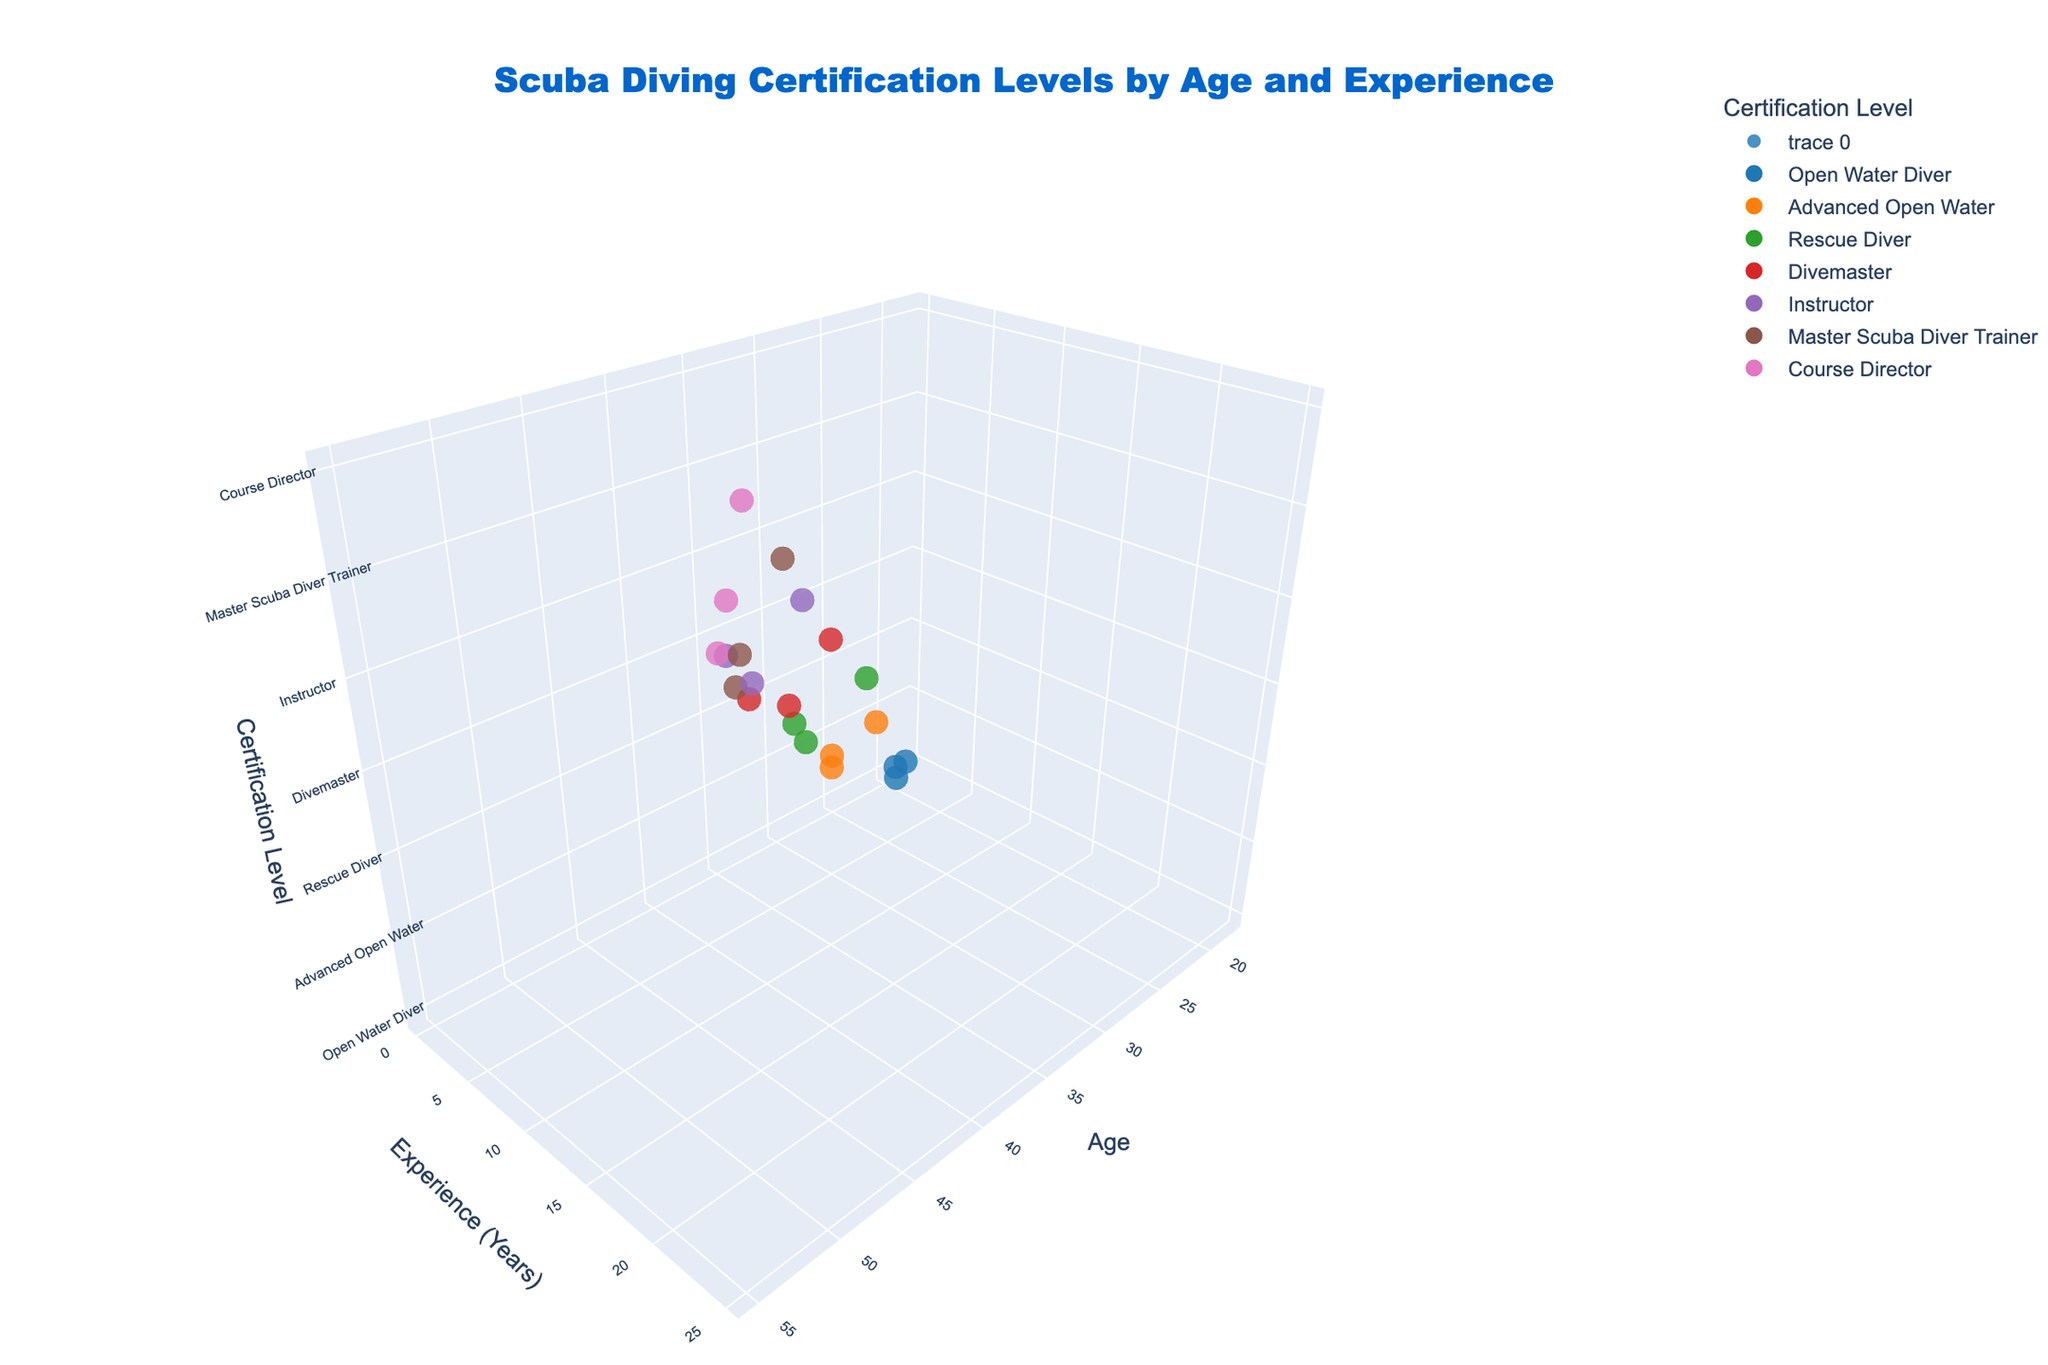What is the title of the plot? The title is usually positioned at the top-middle of the figure, it is typically larger and bolder than other text elements.
Answer: Scuba Diving Certification Levels by Age and Experience At what age does the data point for 'Master Scuba Diver Trainer' with 18 years of experience occur? Follow the x-axis to locate the age and then check the data point matching 'Master Scuba Diver Trainer' with 18 years of experience.
Answer: 48 Which certification level has the highest number of data points? Observe the number of markers associated with each certification level across the 3D plot.
Answer: Open Water Diver What age range covers 'Course Director' certification levels? Look at the x-axis values related to 'Course Director' markers to determine the age range.
Answer: 45 to 55 What is the relationship between age and experience? Observe the trend by comparing the positions of markers with respect to age and experience axes—generally, older individuals have more experience.
Answer: Positive correlation What are the ages of individuals with 'Instructor' certification? Identify the points labeled 'Instructor' and observe their positions along the x-axis (age).
Answer: 35, 42, 43 Is there any 'Open Water Diver' certification for individuals above age 25? Look for 'Open Water Diver' markers and check if any of them are positioned beyond age 25 on the x-axis.
Answer: No Compare the ages and experience years of the youngest and oldest 'Divemaster' certified individuals. Identify the 'Divemaster' points and find the minimum and maximum age and corresponding experience years for each.
Answer: Youngest: 30 years, 5 years; Oldest: 38 years, 7 years How does the number of years of experience differ between someone who is 25 years old with 'Rescue Diver' certification and someone who is 33 years old with the same certification? Locate the 'Rescue Diver' points at ages 25 and 33, and check the y-axis values to determine the experience years at those ages.
Answer: 3 years vs. 6 years 